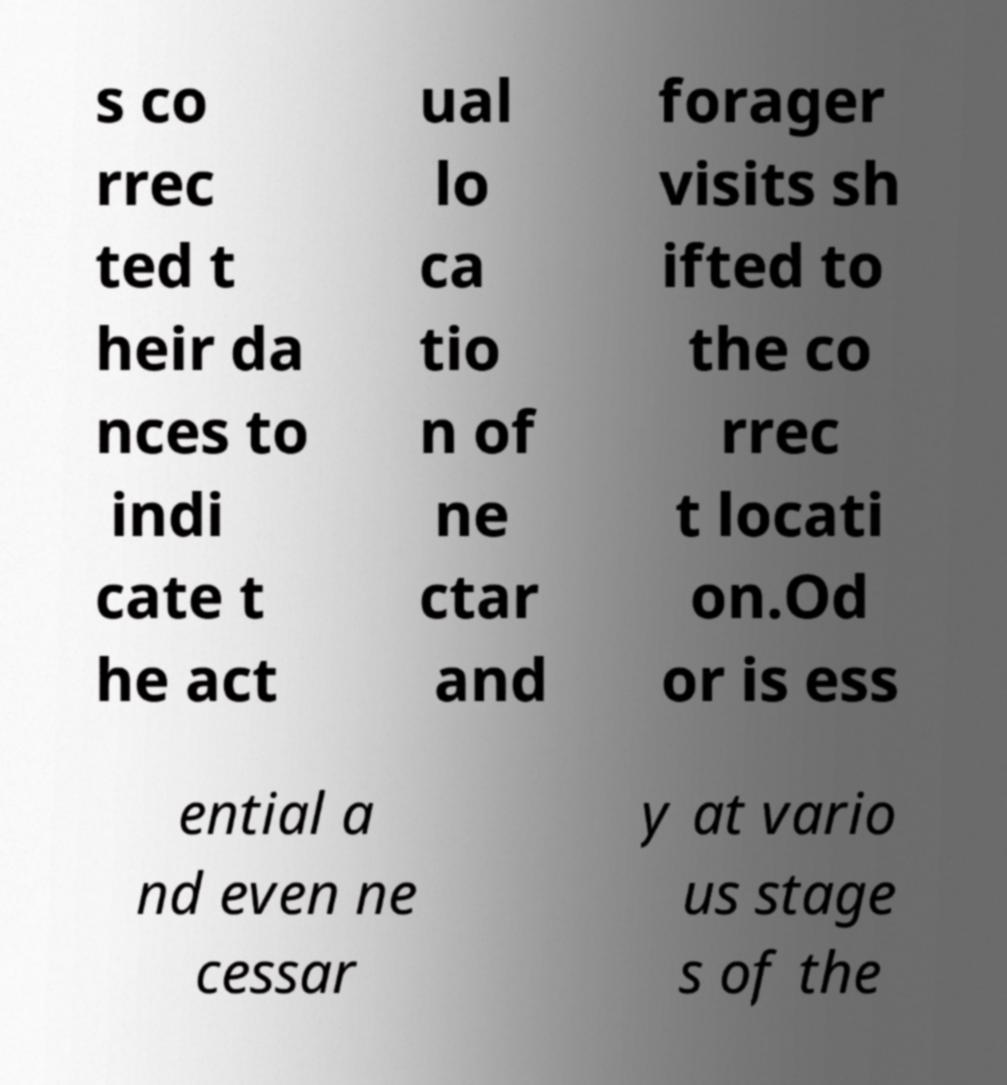Please read and relay the text visible in this image. What does it say? s co rrec ted t heir da nces to indi cate t he act ual lo ca tio n of ne ctar and forager visits sh ifted to the co rrec t locati on.Od or is ess ential a nd even ne cessar y at vario us stage s of the 